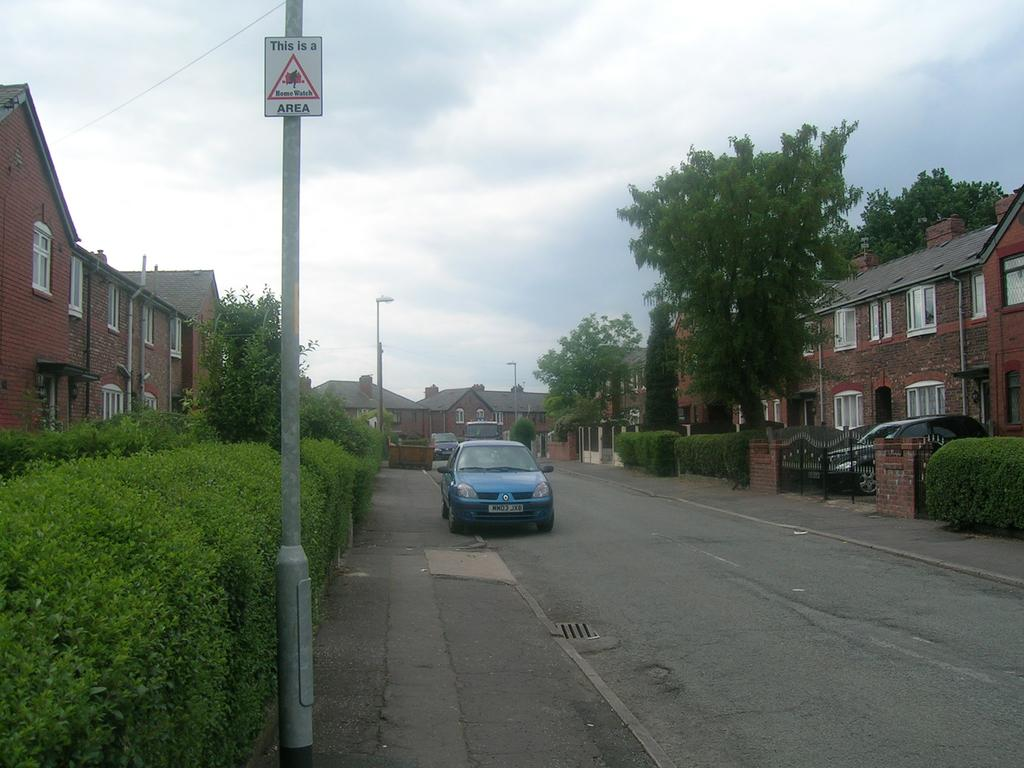What is the main subject in the middle of the image? There is a blue car in the middle of the image. Where is the car located? The car is on the road. What can be seen on the left side of the image? There are bushes and houses on the left side of the image. What type of vegetation is on the right side of the image? There are trees on the right side of the image. What is visible at the top of the image? The sky is visible at the top of the image. What scent can be detected coming from the key in the image? There is no key present in the image, so it is not possible to determine any scent associated with it. 